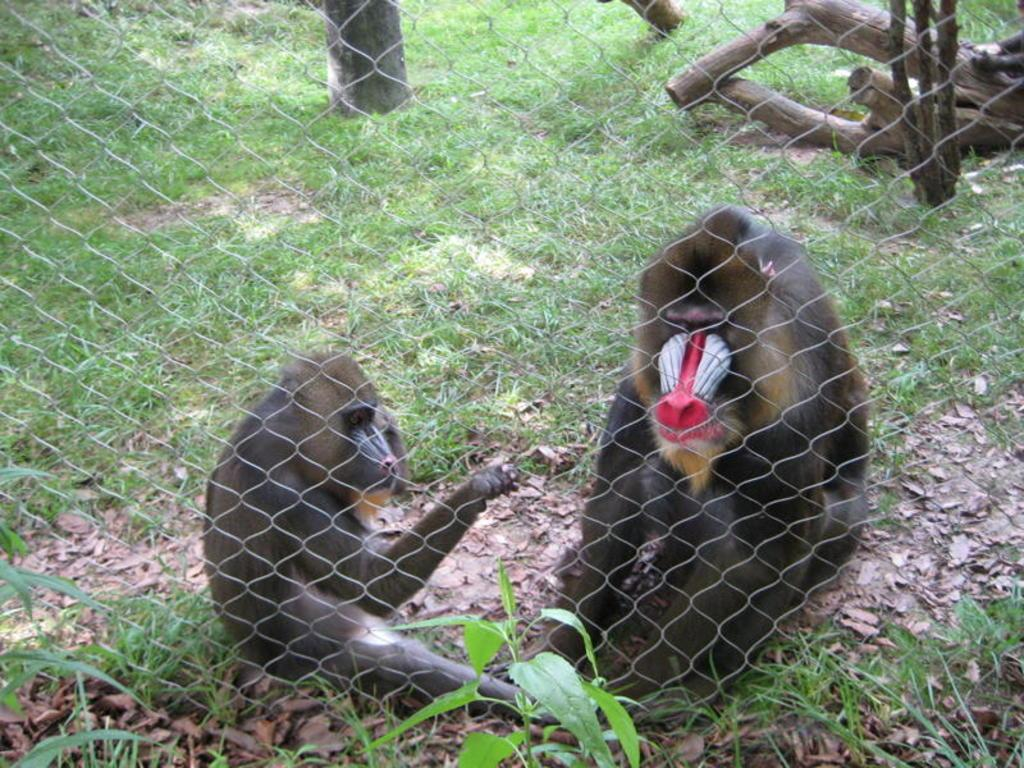What animals are sitting on the ground in the image? There are two monkeys sitting on the ground in the image. What type of vegetation can be seen in the image? There is a tree, plants, and grass in the image. What is the barrier surrounding the area in the image? There is a fence in the image. What objects are lying on the ground in the image? There are wooden sticks on the ground in the image. What type of print can be seen on the umbrella in the image? There is no umbrella present in the image; it only features two monkeys, a tree, plants, grass, a fence, and wooden sticks. 